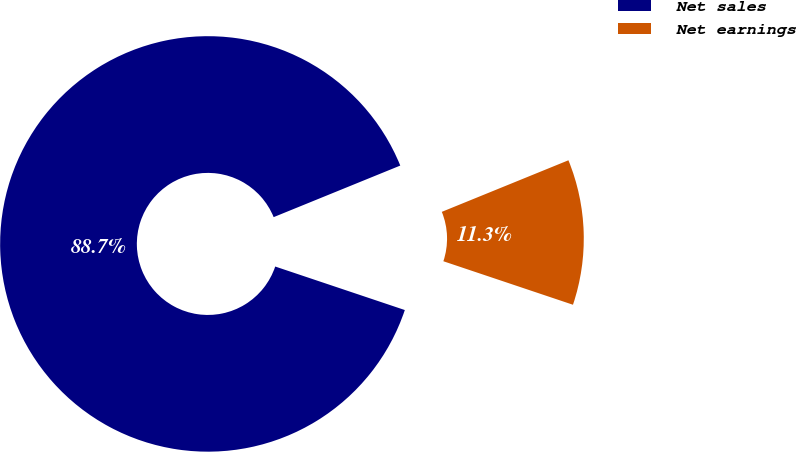Convert chart. <chart><loc_0><loc_0><loc_500><loc_500><pie_chart><fcel>Net sales<fcel>Net earnings<nl><fcel>88.69%<fcel>11.31%<nl></chart> 